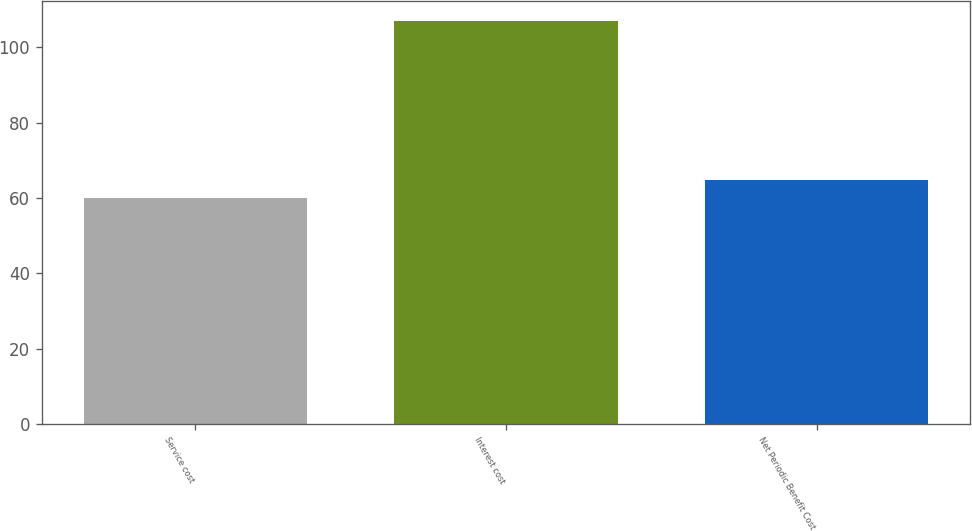Convert chart to OTSL. <chart><loc_0><loc_0><loc_500><loc_500><bar_chart><fcel>Service cost<fcel>Interest cost<fcel>Net Periodic Benefit Cost<nl><fcel>60<fcel>107<fcel>64.7<nl></chart> 